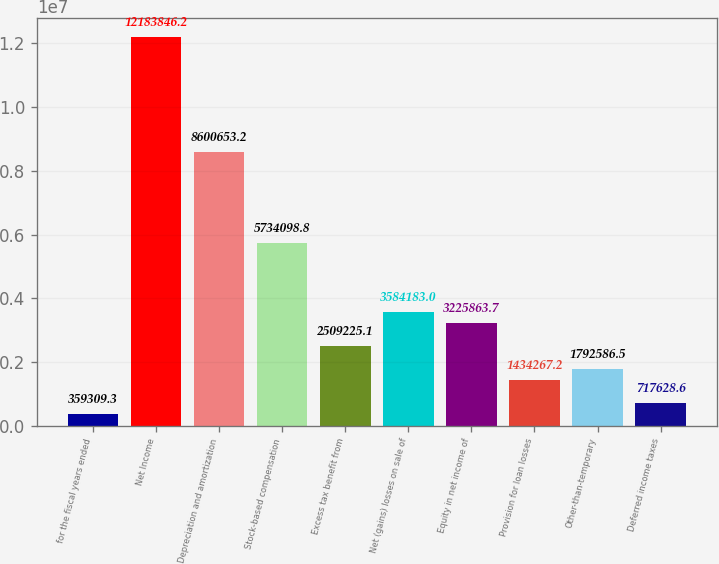<chart> <loc_0><loc_0><loc_500><loc_500><bar_chart><fcel>for the fiscal years ended<fcel>Net Income<fcel>Depreciation and amortization<fcel>Stock-based compensation<fcel>Excess tax benefit from<fcel>Net (gains) losses on sale of<fcel>Equity in net income of<fcel>Provision for loan losses<fcel>Other-than-temporary<fcel>Deferred income taxes<nl><fcel>359309<fcel>1.21838e+07<fcel>8.60065e+06<fcel>5.7341e+06<fcel>2.50923e+06<fcel>3.58418e+06<fcel>3.22586e+06<fcel>1.43427e+06<fcel>1.79259e+06<fcel>717629<nl></chart> 